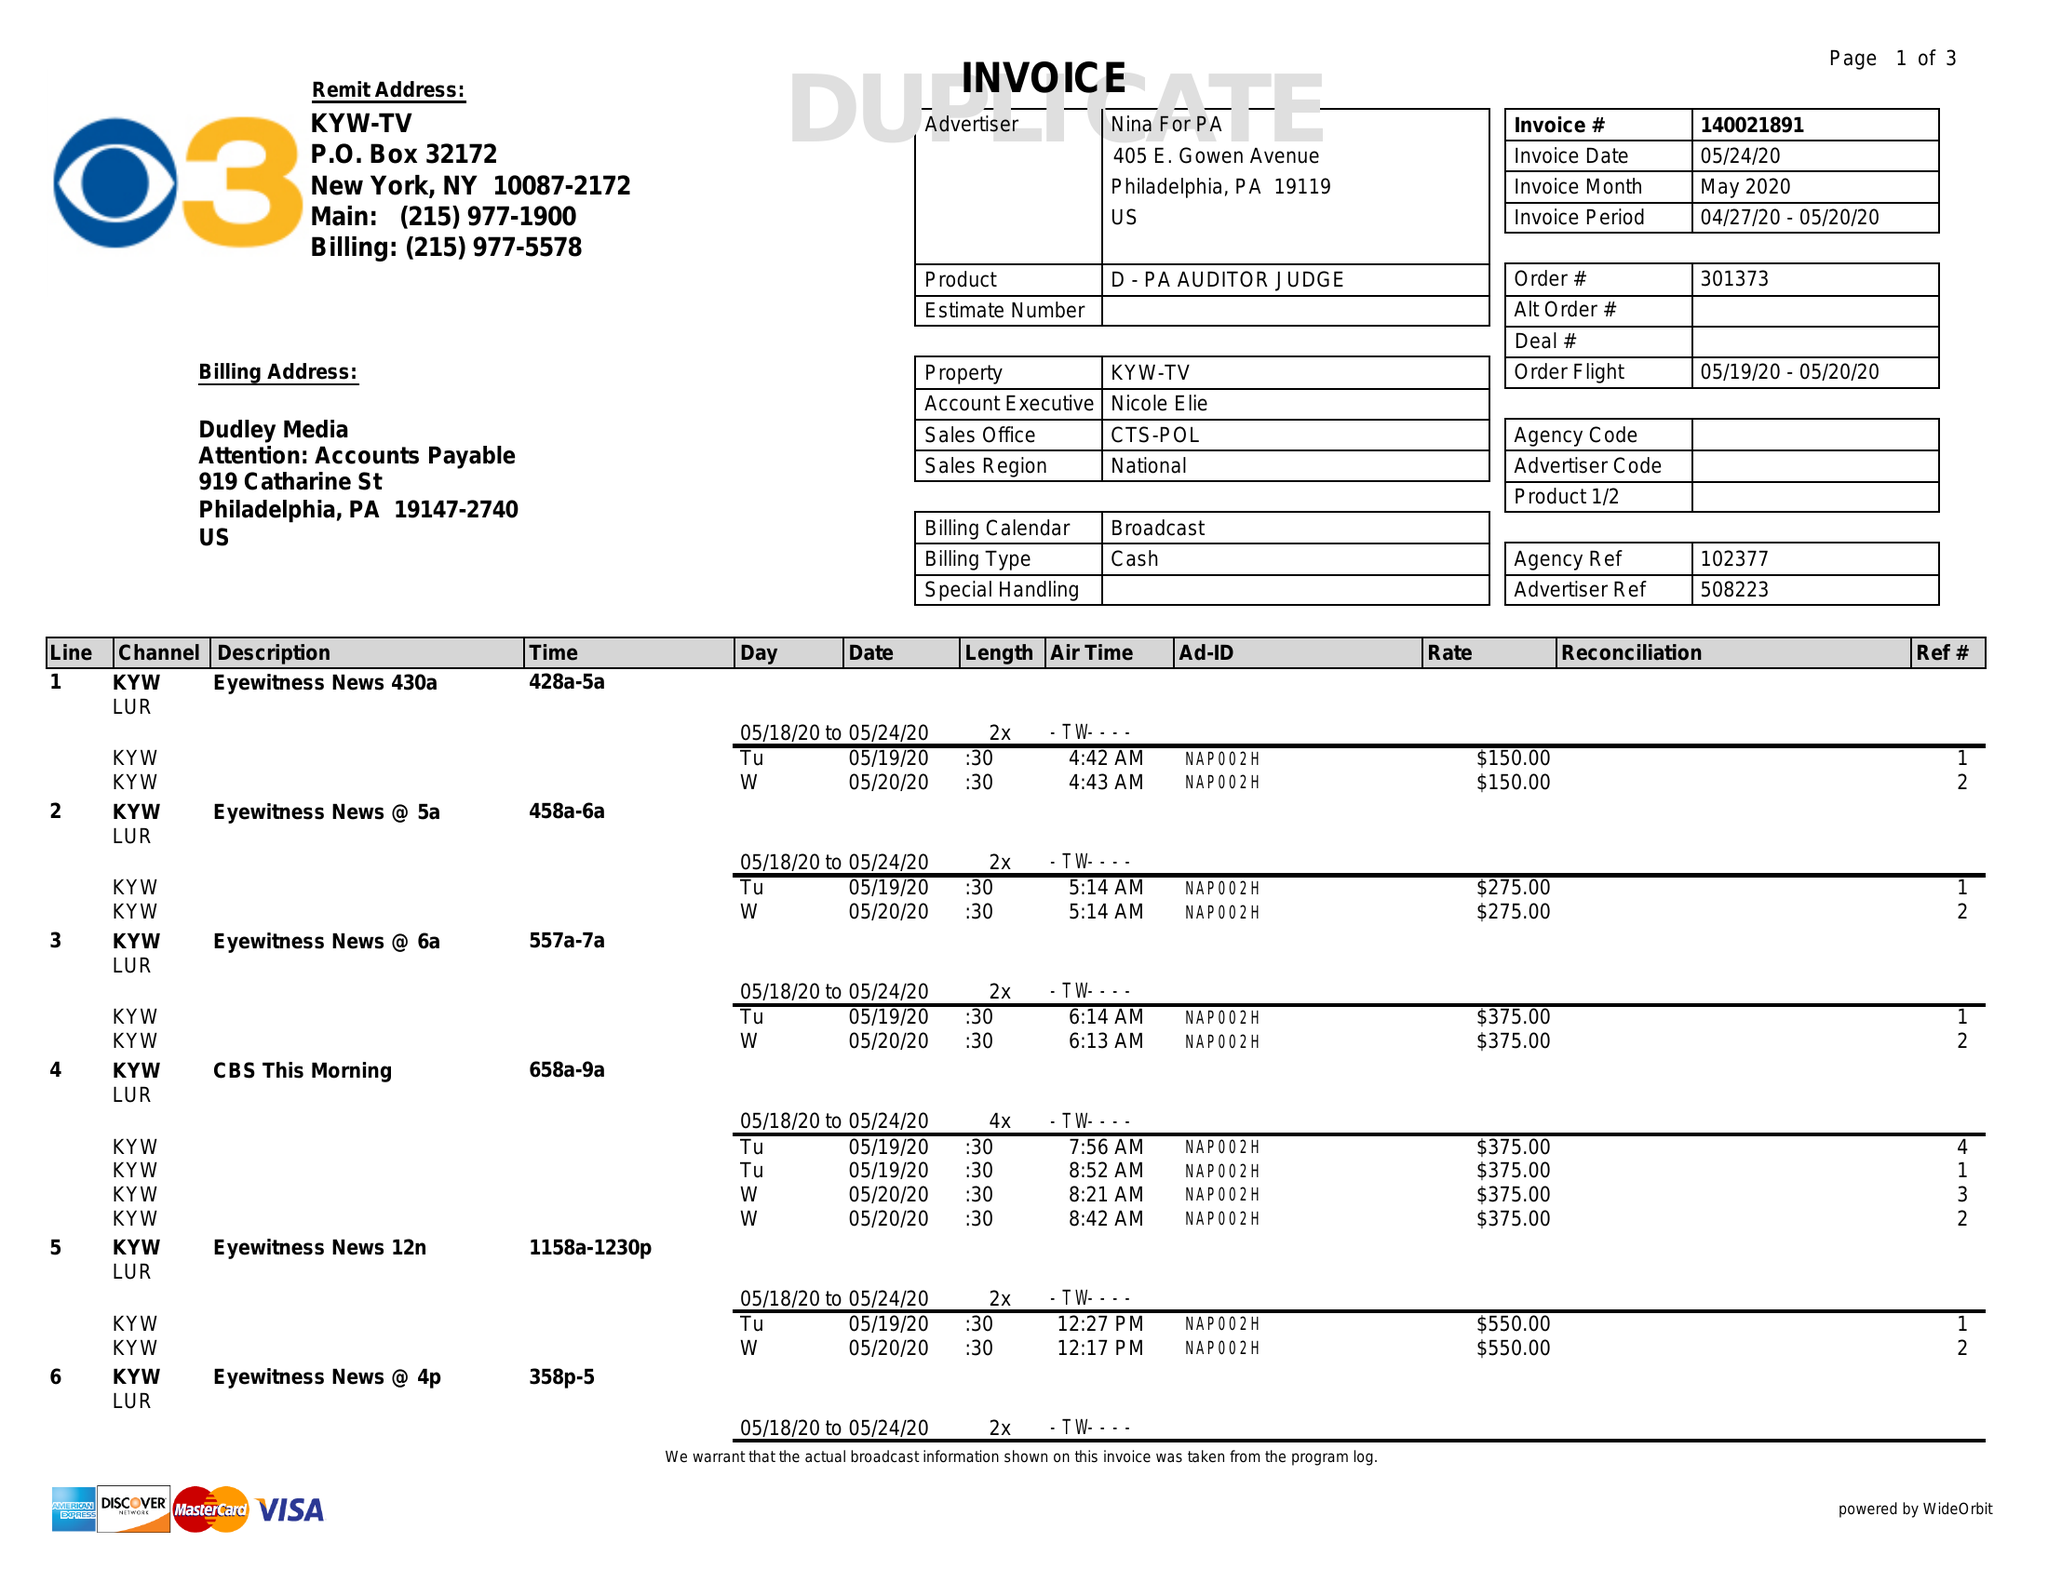What is the value for the advertiser?
Answer the question using a single word or phrase. NINA FOR PA 